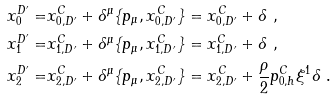<formula> <loc_0><loc_0><loc_500><loc_500>x _ { 0 } ^ { D ^ { \prime } } = & x _ { 0 , D ^ { \prime } } ^ { C } + \delta ^ { \mu } \{ p _ { \mu } , x _ { 0 , D ^ { \prime } } ^ { C } \} = x _ { 0 , D ^ { \prime } } ^ { C } + \delta \ , \\ x _ { 1 } ^ { D ^ { \prime } } = & x _ { 1 , D ^ { \prime } } ^ { C } + \delta ^ { \mu } \{ p _ { \mu } , x _ { 1 , D ^ { \prime } } ^ { C } \} = x _ { 1 , D ^ { \prime } } ^ { C } + \delta \ , \\ x _ { 2 } ^ { D ^ { \prime } } = & x _ { 2 , D ^ { \prime } } ^ { C } + \delta ^ { \mu } \{ p _ { \mu } , x _ { 2 , D ^ { \prime } } ^ { C } \} = x _ { 2 , D ^ { \prime } } ^ { C } + \frac { \rho } { 2 } p _ { 0 , h } ^ { C } \xi ^ { 1 } \delta \ .</formula> 